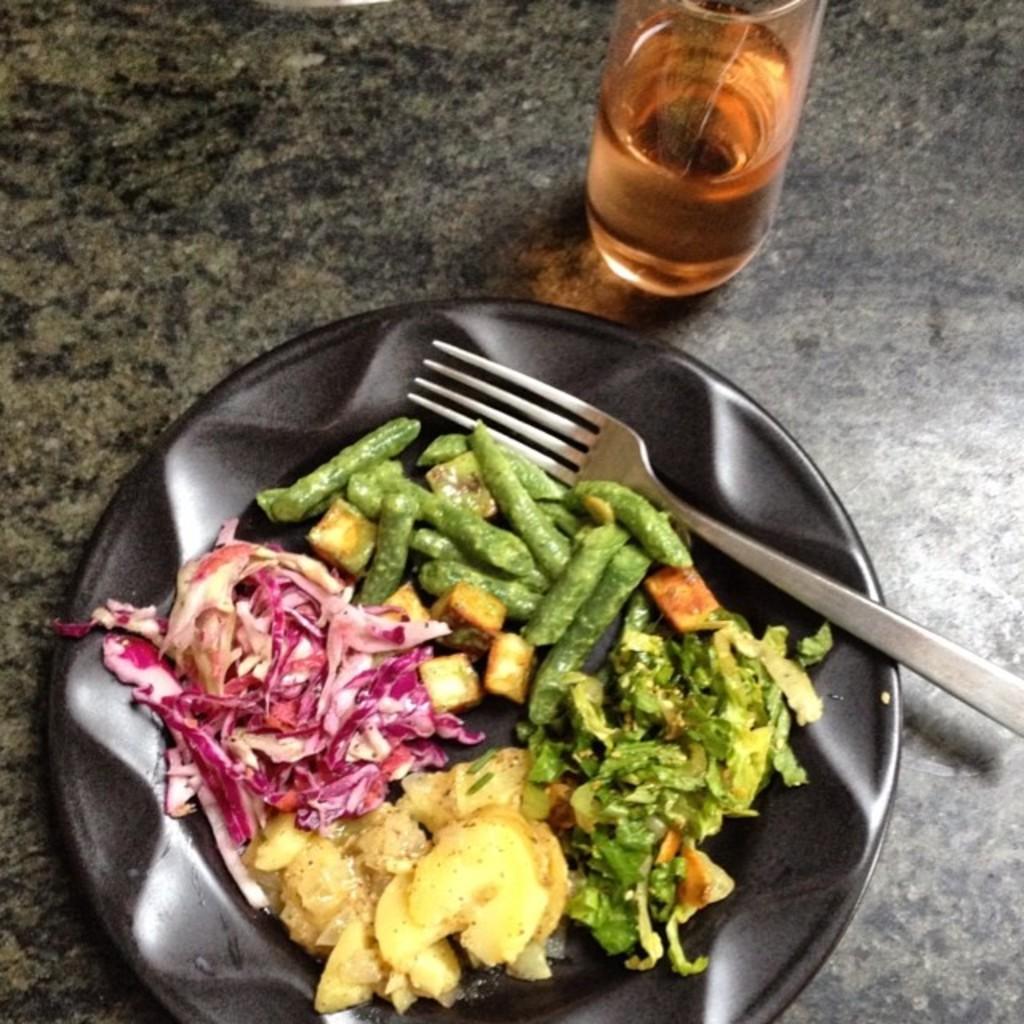Could you give a brief overview of what you see in this image? In this image I can see the plate with food. The food is in pink, cream and green color and the plate is in black color. I can see the fork in the plate. To the side I can see the bottle. These are on the surface. 